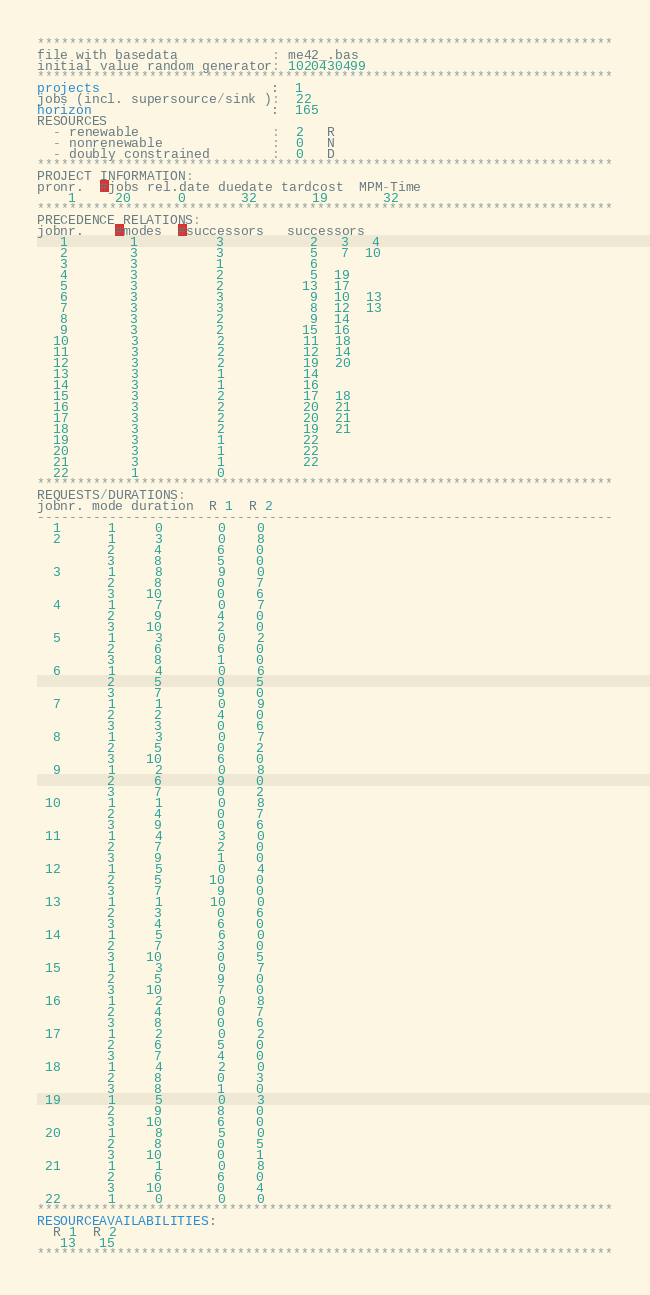<code> <loc_0><loc_0><loc_500><loc_500><_ObjectiveC_>************************************************************************
file with basedata            : me42_.bas
initial value random generator: 1020430499
************************************************************************
projects                      :  1
jobs (incl. supersource/sink ):  22
horizon                       :  165
RESOURCES
  - renewable                 :  2   R
  - nonrenewable              :  0   N
  - doubly constrained        :  0   D
************************************************************************
PROJECT INFORMATION:
pronr.  #jobs rel.date duedate tardcost  MPM-Time
    1     20      0       32       19       32
************************************************************************
PRECEDENCE RELATIONS:
jobnr.    #modes  #successors   successors
   1        1          3           2   3   4
   2        3          3           5   7  10
   3        3          1           6
   4        3          2           5  19
   5        3          2          13  17
   6        3          3           9  10  13
   7        3          3           8  12  13
   8        3          2           9  14
   9        3          2          15  16
  10        3          2          11  18
  11        3          2          12  14
  12        3          2          19  20
  13        3          1          14
  14        3          1          16
  15        3          2          17  18
  16        3          2          20  21
  17        3          2          20  21
  18        3          2          19  21
  19        3          1          22
  20        3          1          22
  21        3          1          22
  22        1          0        
************************************************************************
REQUESTS/DURATIONS:
jobnr. mode duration  R 1  R 2
------------------------------------------------------------------------
  1      1     0       0    0
  2      1     3       0    8
         2     4       6    0
         3     8       5    0
  3      1     8       9    0
         2     8       0    7
         3    10       0    6
  4      1     7       0    7
         2     9       4    0
         3    10       2    0
  5      1     3       0    2
         2     6       6    0
         3     8       1    0
  6      1     4       0    6
         2     5       0    5
         3     7       9    0
  7      1     1       0    9
         2     2       4    0
         3     3       0    6
  8      1     3       0    7
         2     5       0    2
         3    10       6    0
  9      1     2       0    8
         2     6       9    0
         3     7       0    2
 10      1     1       0    8
         2     4       0    7
         3     9       0    6
 11      1     4       3    0
         2     7       2    0
         3     9       1    0
 12      1     5       0    4
         2     5      10    0
         3     7       9    0
 13      1     1      10    0
         2     3       0    6
         3     4       6    0
 14      1     5       6    0
         2     7       3    0
         3    10       0    5
 15      1     3       0    7
         2     5       9    0
         3    10       7    0
 16      1     2       0    8
         2     4       0    7
         3     8       0    6
 17      1     2       0    2
         2     6       5    0
         3     7       4    0
 18      1     4       2    0
         2     8       0    3
         3     8       1    0
 19      1     5       0    3
         2     9       8    0
         3    10       6    0
 20      1     8       5    0
         2     8       0    5
         3    10       0    1
 21      1     1       0    8
         2     6       6    0
         3    10       0    4
 22      1     0       0    0
************************************************************************
RESOURCEAVAILABILITIES:
  R 1  R 2
   13   15
************************************************************************
</code> 